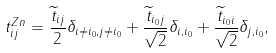<formula> <loc_0><loc_0><loc_500><loc_500>t _ { i j } ^ { Z n } = \frac { \widetilde { t } _ { i j } } 2 \delta _ { i \neq i _ { 0 } , j \neq i _ { 0 } } + \frac { \widetilde { t } _ { i _ { 0 } j } } { \sqrt { 2 } } \delta _ { i , i _ { 0 } } + \frac { \widetilde { t } _ { i _ { 0 } i } } { \sqrt { 2 } } \delta _ { j , i _ { 0 } } ,</formula> 